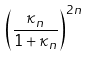<formula> <loc_0><loc_0><loc_500><loc_500>\left ( \frac { \kappa _ { n } } { 1 + \kappa _ { n } } \right ) ^ { 2 n }</formula> 